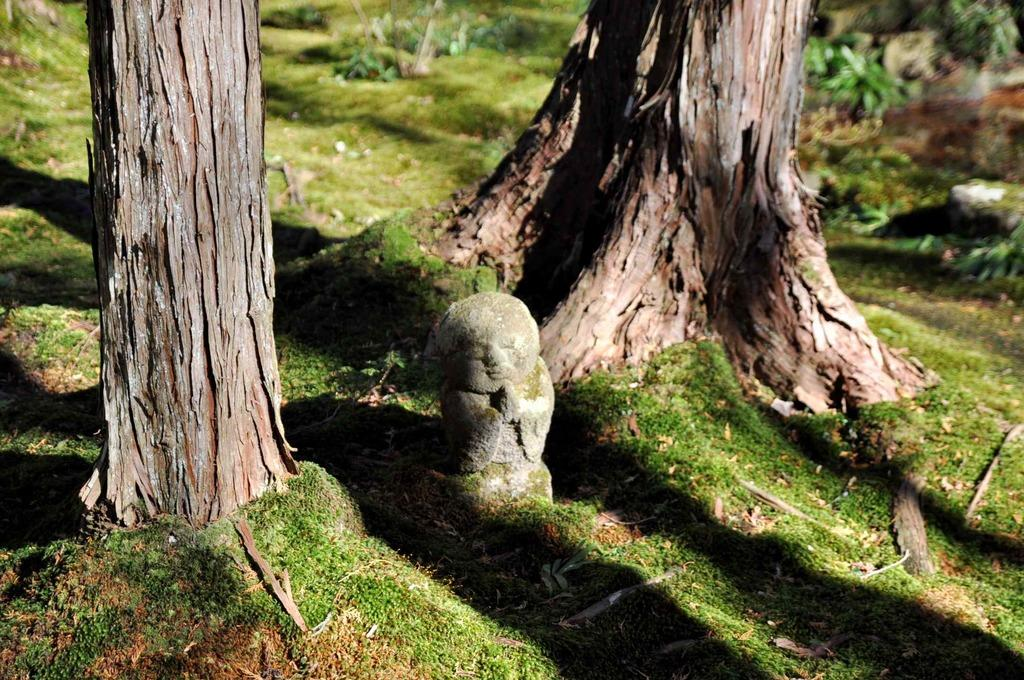What type of natural elements can be seen in the image? There are tree trunks and grass in the image. What man-made object is present in the image? There is a sculpture in the image. What can be seen in the background of the image? In the background of the image, there are plants, grass, and other objects. Where is the grass located in the image? The grass is at the bottom of the image. Can you hear the monkey making noise in the image? There is no monkey present in the image, so it is not possible to hear any noise it might make. 